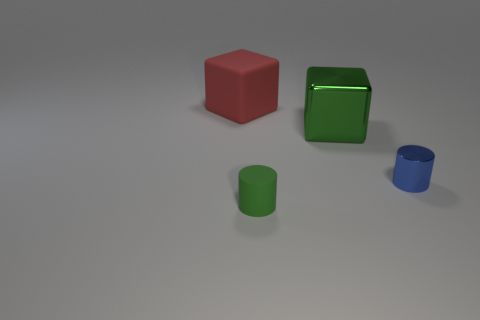Add 1 big red metallic cylinders. How many objects exist? 5 Subtract 0 yellow cubes. How many objects are left? 4 Subtract all matte things. Subtract all large red matte blocks. How many objects are left? 1 Add 4 tiny green rubber objects. How many tiny green rubber objects are left? 5 Add 4 small metal objects. How many small metal objects exist? 5 